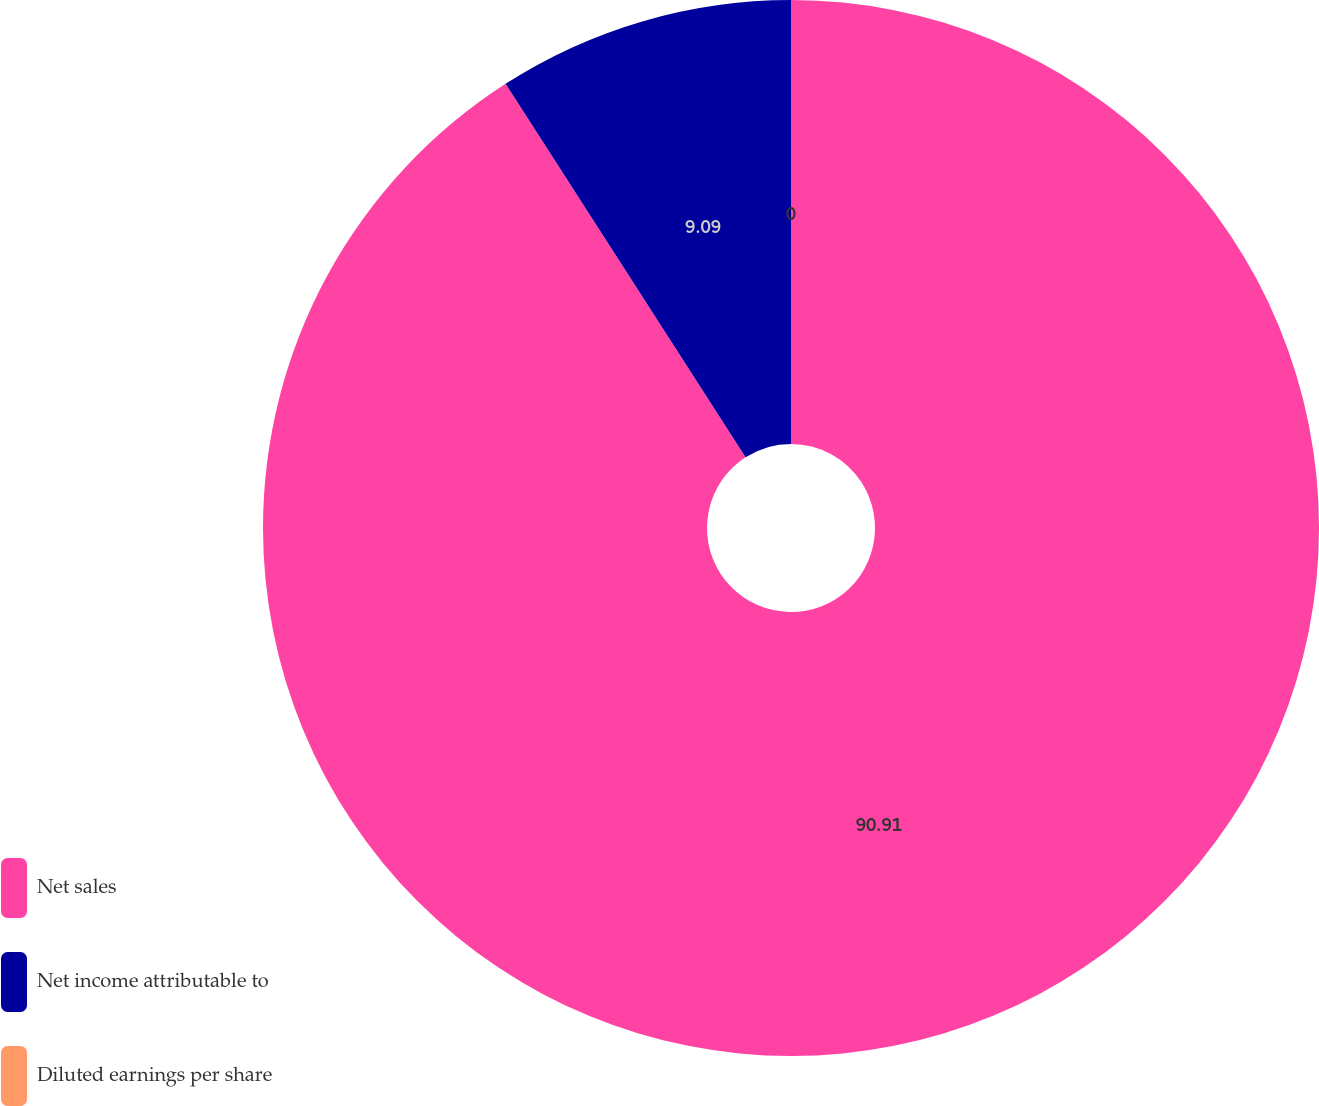Convert chart to OTSL. <chart><loc_0><loc_0><loc_500><loc_500><pie_chart><fcel>Net sales<fcel>Net income attributable to<fcel>Diluted earnings per share<nl><fcel>90.91%<fcel>9.09%<fcel>0.0%<nl></chart> 